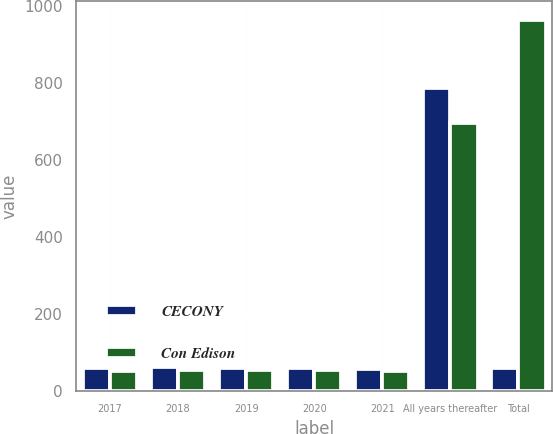<chart> <loc_0><loc_0><loc_500><loc_500><stacked_bar_chart><ecel><fcel>2017<fcel>2018<fcel>2019<fcel>2020<fcel>2021<fcel>All years thereafter<fcel>Total<nl><fcel>CECONY<fcel>61<fcel>62<fcel>61<fcel>61<fcel>58<fcel>788<fcel>61<nl><fcel>Con Edison<fcel>53<fcel>54<fcel>54<fcel>54<fcel>53<fcel>696<fcel>964<nl></chart> 